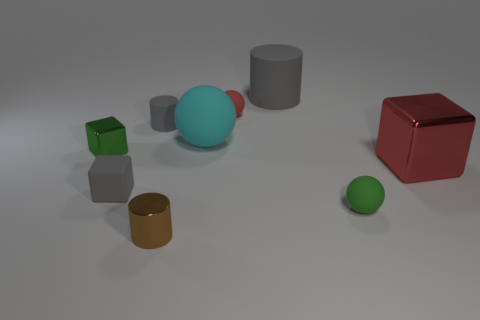What texture do most of the objects in this image have? Most objects in the image appear to have a matte texture, which diffuses light and minimizes reflections. 